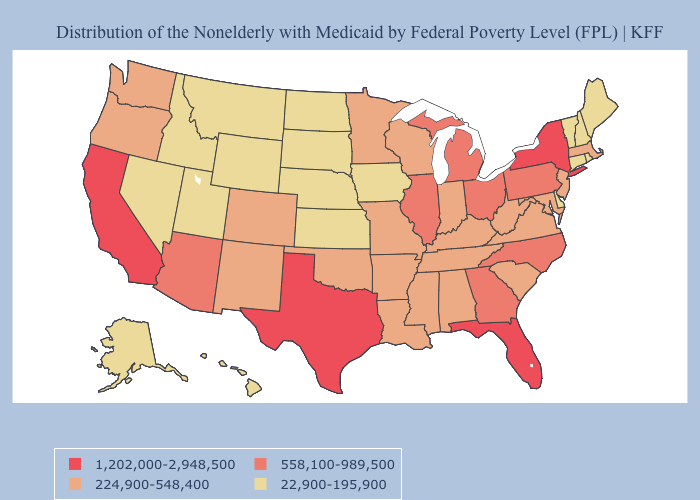Does North Carolina have the highest value in the USA?
Short answer required. No. What is the value of South Dakota?
Give a very brief answer. 22,900-195,900. What is the lowest value in the USA?
Answer briefly. 22,900-195,900. What is the value of Louisiana?
Short answer required. 224,900-548,400. Does Pennsylvania have the highest value in the USA?
Keep it brief. No. Does the map have missing data?
Concise answer only. No. Does West Virginia have a higher value than Idaho?
Keep it brief. Yes. Name the states that have a value in the range 1,202,000-2,948,500?
Be succinct. California, Florida, New York, Texas. Among the states that border Arkansas , does Texas have the highest value?
Write a very short answer. Yes. What is the highest value in the USA?
Write a very short answer. 1,202,000-2,948,500. What is the value of Nevada?
Give a very brief answer. 22,900-195,900. What is the value of North Carolina?
Write a very short answer. 558,100-989,500. How many symbols are there in the legend?
Concise answer only. 4. Does Texas have the highest value in the USA?
Answer briefly. Yes. Among the states that border South Carolina , which have the lowest value?
Short answer required. Georgia, North Carolina. 